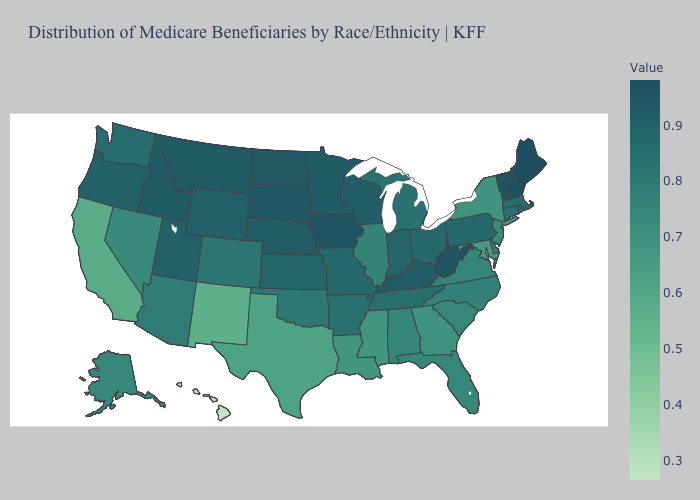Does Hawaii have the lowest value in the USA?
Write a very short answer. Yes. Which states have the lowest value in the Northeast?
Be succinct. New York. Which states have the highest value in the USA?
Write a very short answer. Maine. Does Wisconsin have the highest value in the MidWest?
Short answer required. No. 